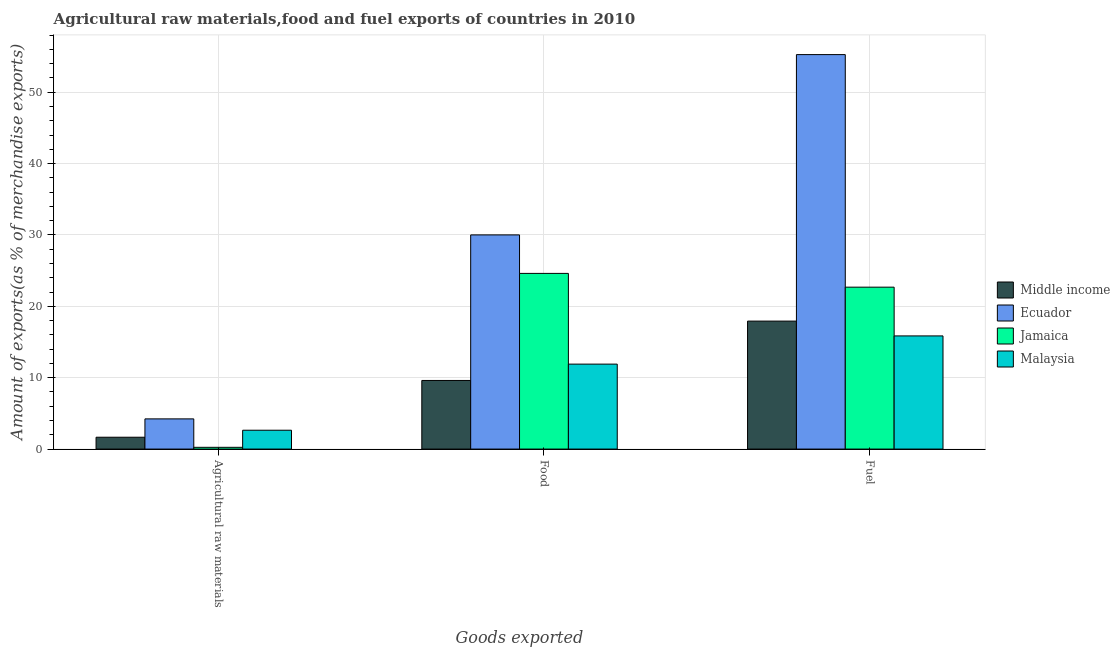How many different coloured bars are there?
Make the answer very short. 4. Are the number of bars on each tick of the X-axis equal?
Your response must be concise. Yes. How many bars are there on the 2nd tick from the left?
Offer a very short reply. 4. How many bars are there on the 2nd tick from the right?
Provide a succinct answer. 4. What is the label of the 3rd group of bars from the left?
Provide a short and direct response. Fuel. What is the percentage of raw materials exports in Middle income?
Offer a terse response. 1.66. Across all countries, what is the maximum percentage of food exports?
Make the answer very short. 30.01. Across all countries, what is the minimum percentage of fuel exports?
Make the answer very short. 15.86. In which country was the percentage of food exports maximum?
Your answer should be very brief. Ecuador. In which country was the percentage of fuel exports minimum?
Provide a succinct answer. Malaysia. What is the total percentage of fuel exports in the graph?
Your answer should be very brief. 111.76. What is the difference between the percentage of fuel exports in Jamaica and that in Middle income?
Make the answer very short. 4.76. What is the difference between the percentage of fuel exports in Middle income and the percentage of food exports in Jamaica?
Your answer should be compact. -6.69. What is the average percentage of raw materials exports per country?
Keep it short and to the point. 2.19. What is the difference between the percentage of raw materials exports and percentage of fuel exports in Malaysia?
Your answer should be compact. -13.22. What is the ratio of the percentage of food exports in Middle income to that in Ecuador?
Your response must be concise. 0.32. Is the percentage of fuel exports in Jamaica less than that in Ecuador?
Your answer should be compact. Yes. Is the difference between the percentage of raw materials exports in Middle income and Jamaica greater than the difference between the percentage of food exports in Middle income and Jamaica?
Make the answer very short. Yes. What is the difference between the highest and the second highest percentage of food exports?
Provide a short and direct response. 5.39. What is the difference between the highest and the lowest percentage of raw materials exports?
Your response must be concise. 3.98. What does the 4th bar from the left in Food represents?
Provide a succinct answer. Malaysia. What does the 1st bar from the right in Fuel represents?
Ensure brevity in your answer.  Malaysia. Is it the case that in every country, the sum of the percentage of raw materials exports and percentage of food exports is greater than the percentage of fuel exports?
Provide a succinct answer. No. How many countries are there in the graph?
Keep it short and to the point. 4. Does the graph contain any zero values?
Keep it short and to the point. No. Where does the legend appear in the graph?
Provide a short and direct response. Center right. How many legend labels are there?
Your answer should be compact. 4. What is the title of the graph?
Ensure brevity in your answer.  Agricultural raw materials,food and fuel exports of countries in 2010. What is the label or title of the X-axis?
Give a very brief answer. Goods exported. What is the label or title of the Y-axis?
Ensure brevity in your answer.  Amount of exports(as % of merchandise exports). What is the Amount of exports(as % of merchandise exports) of Middle income in Agricultural raw materials?
Your answer should be very brief. 1.66. What is the Amount of exports(as % of merchandise exports) of Ecuador in Agricultural raw materials?
Give a very brief answer. 4.23. What is the Amount of exports(as % of merchandise exports) of Jamaica in Agricultural raw materials?
Your answer should be compact. 0.25. What is the Amount of exports(as % of merchandise exports) of Malaysia in Agricultural raw materials?
Make the answer very short. 2.64. What is the Amount of exports(as % of merchandise exports) of Middle income in Food?
Your answer should be very brief. 9.62. What is the Amount of exports(as % of merchandise exports) in Ecuador in Food?
Provide a succinct answer. 30.01. What is the Amount of exports(as % of merchandise exports) of Jamaica in Food?
Keep it short and to the point. 24.62. What is the Amount of exports(as % of merchandise exports) in Malaysia in Food?
Provide a succinct answer. 11.9. What is the Amount of exports(as % of merchandise exports) in Middle income in Fuel?
Offer a terse response. 17.93. What is the Amount of exports(as % of merchandise exports) in Ecuador in Fuel?
Your answer should be compact. 55.28. What is the Amount of exports(as % of merchandise exports) of Jamaica in Fuel?
Give a very brief answer. 22.69. What is the Amount of exports(as % of merchandise exports) of Malaysia in Fuel?
Give a very brief answer. 15.86. Across all Goods exported, what is the maximum Amount of exports(as % of merchandise exports) of Middle income?
Keep it short and to the point. 17.93. Across all Goods exported, what is the maximum Amount of exports(as % of merchandise exports) of Ecuador?
Ensure brevity in your answer.  55.28. Across all Goods exported, what is the maximum Amount of exports(as % of merchandise exports) of Jamaica?
Offer a very short reply. 24.62. Across all Goods exported, what is the maximum Amount of exports(as % of merchandise exports) of Malaysia?
Make the answer very short. 15.86. Across all Goods exported, what is the minimum Amount of exports(as % of merchandise exports) in Middle income?
Your answer should be compact. 1.66. Across all Goods exported, what is the minimum Amount of exports(as % of merchandise exports) in Ecuador?
Your answer should be very brief. 4.23. Across all Goods exported, what is the minimum Amount of exports(as % of merchandise exports) in Jamaica?
Make the answer very short. 0.25. Across all Goods exported, what is the minimum Amount of exports(as % of merchandise exports) of Malaysia?
Offer a terse response. 2.64. What is the total Amount of exports(as % of merchandise exports) in Middle income in the graph?
Offer a very short reply. 29.21. What is the total Amount of exports(as % of merchandise exports) of Ecuador in the graph?
Keep it short and to the point. 89.52. What is the total Amount of exports(as % of merchandise exports) of Jamaica in the graph?
Keep it short and to the point. 47.55. What is the total Amount of exports(as % of merchandise exports) in Malaysia in the graph?
Make the answer very short. 30.4. What is the difference between the Amount of exports(as % of merchandise exports) of Middle income in Agricultural raw materials and that in Food?
Keep it short and to the point. -7.96. What is the difference between the Amount of exports(as % of merchandise exports) of Ecuador in Agricultural raw materials and that in Food?
Your response must be concise. -25.78. What is the difference between the Amount of exports(as % of merchandise exports) in Jamaica in Agricultural raw materials and that in Food?
Give a very brief answer. -24.37. What is the difference between the Amount of exports(as % of merchandise exports) in Malaysia in Agricultural raw materials and that in Food?
Make the answer very short. -9.26. What is the difference between the Amount of exports(as % of merchandise exports) of Middle income in Agricultural raw materials and that in Fuel?
Make the answer very short. -16.27. What is the difference between the Amount of exports(as % of merchandise exports) of Ecuador in Agricultural raw materials and that in Fuel?
Offer a very short reply. -51.05. What is the difference between the Amount of exports(as % of merchandise exports) in Jamaica in Agricultural raw materials and that in Fuel?
Offer a terse response. -22.44. What is the difference between the Amount of exports(as % of merchandise exports) of Malaysia in Agricultural raw materials and that in Fuel?
Provide a succinct answer. -13.22. What is the difference between the Amount of exports(as % of merchandise exports) in Middle income in Food and that in Fuel?
Keep it short and to the point. -8.32. What is the difference between the Amount of exports(as % of merchandise exports) in Ecuador in Food and that in Fuel?
Provide a short and direct response. -25.27. What is the difference between the Amount of exports(as % of merchandise exports) in Jamaica in Food and that in Fuel?
Provide a succinct answer. 1.93. What is the difference between the Amount of exports(as % of merchandise exports) of Malaysia in Food and that in Fuel?
Keep it short and to the point. -3.95. What is the difference between the Amount of exports(as % of merchandise exports) in Middle income in Agricultural raw materials and the Amount of exports(as % of merchandise exports) in Ecuador in Food?
Provide a short and direct response. -28.35. What is the difference between the Amount of exports(as % of merchandise exports) in Middle income in Agricultural raw materials and the Amount of exports(as % of merchandise exports) in Jamaica in Food?
Your response must be concise. -22.96. What is the difference between the Amount of exports(as % of merchandise exports) of Middle income in Agricultural raw materials and the Amount of exports(as % of merchandise exports) of Malaysia in Food?
Offer a terse response. -10.24. What is the difference between the Amount of exports(as % of merchandise exports) in Ecuador in Agricultural raw materials and the Amount of exports(as % of merchandise exports) in Jamaica in Food?
Your answer should be compact. -20.39. What is the difference between the Amount of exports(as % of merchandise exports) of Ecuador in Agricultural raw materials and the Amount of exports(as % of merchandise exports) of Malaysia in Food?
Ensure brevity in your answer.  -7.67. What is the difference between the Amount of exports(as % of merchandise exports) in Jamaica in Agricultural raw materials and the Amount of exports(as % of merchandise exports) in Malaysia in Food?
Offer a very short reply. -11.66. What is the difference between the Amount of exports(as % of merchandise exports) in Middle income in Agricultural raw materials and the Amount of exports(as % of merchandise exports) in Ecuador in Fuel?
Give a very brief answer. -53.62. What is the difference between the Amount of exports(as % of merchandise exports) in Middle income in Agricultural raw materials and the Amount of exports(as % of merchandise exports) in Jamaica in Fuel?
Make the answer very short. -21.03. What is the difference between the Amount of exports(as % of merchandise exports) of Middle income in Agricultural raw materials and the Amount of exports(as % of merchandise exports) of Malaysia in Fuel?
Your response must be concise. -14.2. What is the difference between the Amount of exports(as % of merchandise exports) in Ecuador in Agricultural raw materials and the Amount of exports(as % of merchandise exports) in Jamaica in Fuel?
Your response must be concise. -18.46. What is the difference between the Amount of exports(as % of merchandise exports) of Ecuador in Agricultural raw materials and the Amount of exports(as % of merchandise exports) of Malaysia in Fuel?
Ensure brevity in your answer.  -11.63. What is the difference between the Amount of exports(as % of merchandise exports) of Jamaica in Agricultural raw materials and the Amount of exports(as % of merchandise exports) of Malaysia in Fuel?
Give a very brief answer. -15.61. What is the difference between the Amount of exports(as % of merchandise exports) in Middle income in Food and the Amount of exports(as % of merchandise exports) in Ecuador in Fuel?
Provide a succinct answer. -45.66. What is the difference between the Amount of exports(as % of merchandise exports) in Middle income in Food and the Amount of exports(as % of merchandise exports) in Jamaica in Fuel?
Your answer should be very brief. -13.07. What is the difference between the Amount of exports(as % of merchandise exports) of Middle income in Food and the Amount of exports(as % of merchandise exports) of Malaysia in Fuel?
Provide a succinct answer. -6.24. What is the difference between the Amount of exports(as % of merchandise exports) in Ecuador in Food and the Amount of exports(as % of merchandise exports) in Jamaica in Fuel?
Offer a very short reply. 7.32. What is the difference between the Amount of exports(as % of merchandise exports) of Ecuador in Food and the Amount of exports(as % of merchandise exports) of Malaysia in Fuel?
Make the answer very short. 14.16. What is the difference between the Amount of exports(as % of merchandise exports) of Jamaica in Food and the Amount of exports(as % of merchandise exports) of Malaysia in Fuel?
Provide a succinct answer. 8.76. What is the average Amount of exports(as % of merchandise exports) of Middle income per Goods exported?
Offer a very short reply. 9.74. What is the average Amount of exports(as % of merchandise exports) in Ecuador per Goods exported?
Give a very brief answer. 29.84. What is the average Amount of exports(as % of merchandise exports) in Jamaica per Goods exported?
Offer a terse response. 15.85. What is the average Amount of exports(as % of merchandise exports) of Malaysia per Goods exported?
Provide a succinct answer. 10.13. What is the difference between the Amount of exports(as % of merchandise exports) of Middle income and Amount of exports(as % of merchandise exports) of Ecuador in Agricultural raw materials?
Your answer should be compact. -2.57. What is the difference between the Amount of exports(as % of merchandise exports) in Middle income and Amount of exports(as % of merchandise exports) in Jamaica in Agricultural raw materials?
Offer a terse response. 1.41. What is the difference between the Amount of exports(as % of merchandise exports) of Middle income and Amount of exports(as % of merchandise exports) of Malaysia in Agricultural raw materials?
Provide a succinct answer. -0.98. What is the difference between the Amount of exports(as % of merchandise exports) in Ecuador and Amount of exports(as % of merchandise exports) in Jamaica in Agricultural raw materials?
Your answer should be compact. 3.98. What is the difference between the Amount of exports(as % of merchandise exports) of Ecuador and Amount of exports(as % of merchandise exports) of Malaysia in Agricultural raw materials?
Offer a very short reply. 1.59. What is the difference between the Amount of exports(as % of merchandise exports) in Jamaica and Amount of exports(as % of merchandise exports) in Malaysia in Agricultural raw materials?
Offer a very short reply. -2.39. What is the difference between the Amount of exports(as % of merchandise exports) in Middle income and Amount of exports(as % of merchandise exports) in Ecuador in Food?
Provide a succinct answer. -20.4. What is the difference between the Amount of exports(as % of merchandise exports) of Middle income and Amount of exports(as % of merchandise exports) of Jamaica in Food?
Give a very brief answer. -15. What is the difference between the Amount of exports(as % of merchandise exports) in Middle income and Amount of exports(as % of merchandise exports) in Malaysia in Food?
Make the answer very short. -2.29. What is the difference between the Amount of exports(as % of merchandise exports) of Ecuador and Amount of exports(as % of merchandise exports) of Jamaica in Food?
Keep it short and to the point. 5.39. What is the difference between the Amount of exports(as % of merchandise exports) of Ecuador and Amount of exports(as % of merchandise exports) of Malaysia in Food?
Provide a succinct answer. 18.11. What is the difference between the Amount of exports(as % of merchandise exports) of Jamaica and Amount of exports(as % of merchandise exports) of Malaysia in Food?
Your answer should be very brief. 12.71. What is the difference between the Amount of exports(as % of merchandise exports) in Middle income and Amount of exports(as % of merchandise exports) in Ecuador in Fuel?
Your response must be concise. -37.35. What is the difference between the Amount of exports(as % of merchandise exports) of Middle income and Amount of exports(as % of merchandise exports) of Jamaica in Fuel?
Give a very brief answer. -4.76. What is the difference between the Amount of exports(as % of merchandise exports) in Middle income and Amount of exports(as % of merchandise exports) in Malaysia in Fuel?
Your answer should be compact. 2.08. What is the difference between the Amount of exports(as % of merchandise exports) in Ecuador and Amount of exports(as % of merchandise exports) in Jamaica in Fuel?
Keep it short and to the point. 32.59. What is the difference between the Amount of exports(as % of merchandise exports) of Ecuador and Amount of exports(as % of merchandise exports) of Malaysia in Fuel?
Offer a terse response. 39.42. What is the difference between the Amount of exports(as % of merchandise exports) in Jamaica and Amount of exports(as % of merchandise exports) in Malaysia in Fuel?
Provide a succinct answer. 6.83. What is the ratio of the Amount of exports(as % of merchandise exports) in Middle income in Agricultural raw materials to that in Food?
Offer a terse response. 0.17. What is the ratio of the Amount of exports(as % of merchandise exports) of Ecuador in Agricultural raw materials to that in Food?
Provide a short and direct response. 0.14. What is the ratio of the Amount of exports(as % of merchandise exports) of Jamaica in Agricultural raw materials to that in Food?
Provide a short and direct response. 0.01. What is the ratio of the Amount of exports(as % of merchandise exports) in Malaysia in Agricultural raw materials to that in Food?
Your answer should be very brief. 0.22. What is the ratio of the Amount of exports(as % of merchandise exports) in Middle income in Agricultural raw materials to that in Fuel?
Offer a terse response. 0.09. What is the ratio of the Amount of exports(as % of merchandise exports) of Ecuador in Agricultural raw materials to that in Fuel?
Provide a succinct answer. 0.08. What is the ratio of the Amount of exports(as % of merchandise exports) of Jamaica in Agricultural raw materials to that in Fuel?
Make the answer very short. 0.01. What is the ratio of the Amount of exports(as % of merchandise exports) in Malaysia in Agricultural raw materials to that in Fuel?
Provide a succinct answer. 0.17. What is the ratio of the Amount of exports(as % of merchandise exports) of Middle income in Food to that in Fuel?
Keep it short and to the point. 0.54. What is the ratio of the Amount of exports(as % of merchandise exports) of Ecuador in Food to that in Fuel?
Provide a succinct answer. 0.54. What is the ratio of the Amount of exports(as % of merchandise exports) in Jamaica in Food to that in Fuel?
Provide a short and direct response. 1.09. What is the ratio of the Amount of exports(as % of merchandise exports) in Malaysia in Food to that in Fuel?
Offer a very short reply. 0.75. What is the difference between the highest and the second highest Amount of exports(as % of merchandise exports) of Middle income?
Provide a short and direct response. 8.32. What is the difference between the highest and the second highest Amount of exports(as % of merchandise exports) of Ecuador?
Make the answer very short. 25.27. What is the difference between the highest and the second highest Amount of exports(as % of merchandise exports) of Jamaica?
Provide a succinct answer. 1.93. What is the difference between the highest and the second highest Amount of exports(as % of merchandise exports) of Malaysia?
Ensure brevity in your answer.  3.95. What is the difference between the highest and the lowest Amount of exports(as % of merchandise exports) of Middle income?
Provide a succinct answer. 16.27. What is the difference between the highest and the lowest Amount of exports(as % of merchandise exports) in Ecuador?
Ensure brevity in your answer.  51.05. What is the difference between the highest and the lowest Amount of exports(as % of merchandise exports) of Jamaica?
Offer a terse response. 24.37. What is the difference between the highest and the lowest Amount of exports(as % of merchandise exports) in Malaysia?
Make the answer very short. 13.22. 